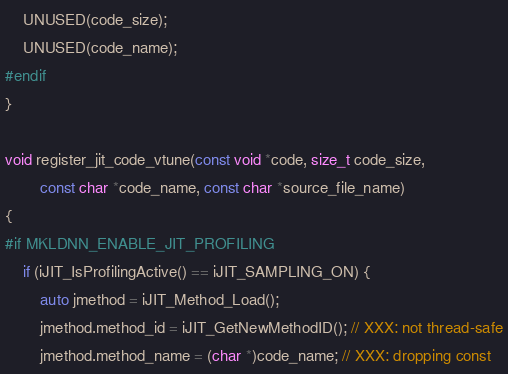<code> <loc_0><loc_0><loc_500><loc_500><_C++_>    UNUSED(code_size);
    UNUSED(code_name);
#endif
}

void register_jit_code_vtune(const void *code, size_t code_size,
        const char *code_name, const char *source_file_name)
{
#if MKLDNN_ENABLE_JIT_PROFILING
    if (iJIT_IsProfilingActive() == iJIT_SAMPLING_ON) {
        auto jmethod = iJIT_Method_Load();
        jmethod.method_id = iJIT_GetNewMethodID(); // XXX: not thread-safe
        jmethod.method_name = (char *)code_name; // XXX: dropping const</code> 